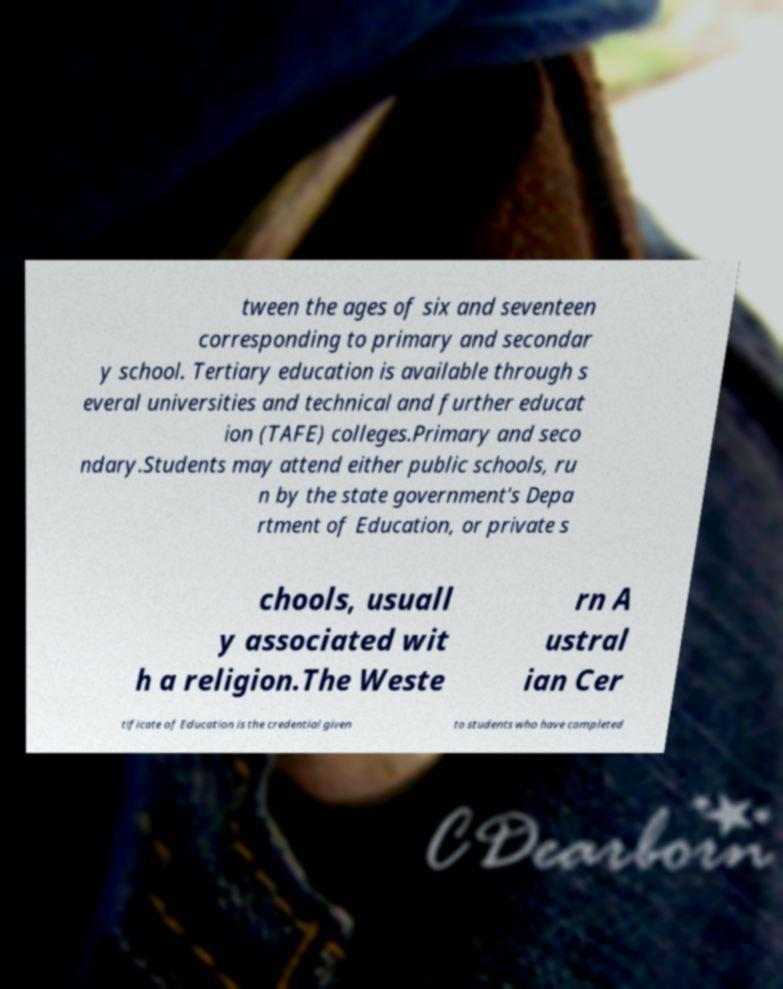There's text embedded in this image that I need extracted. Can you transcribe it verbatim? tween the ages of six and seventeen corresponding to primary and secondar y school. Tertiary education is available through s everal universities and technical and further educat ion (TAFE) colleges.Primary and seco ndary.Students may attend either public schools, ru n by the state government's Depa rtment of Education, or private s chools, usuall y associated wit h a religion.The Weste rn A ustral ian Cer tificate of Education is the credential given to students who have completed 